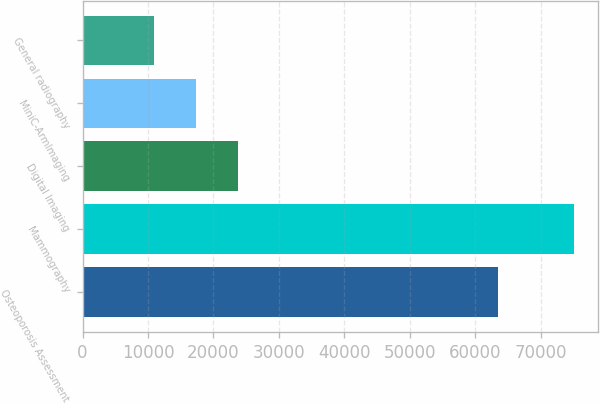<chart> <loc_0><loc_0><loc_500><loc_500><bar_chart><fcel>Osteoporosis Assessment<fcel>Mammography<fcel>Digital Imaging<fcel>MiniC-ArmImaging<fcel>General radiography<nl><fcel>63544<fcel>75039<fcel>23743<fcel>17331<fcel>10919<nl></chart> 